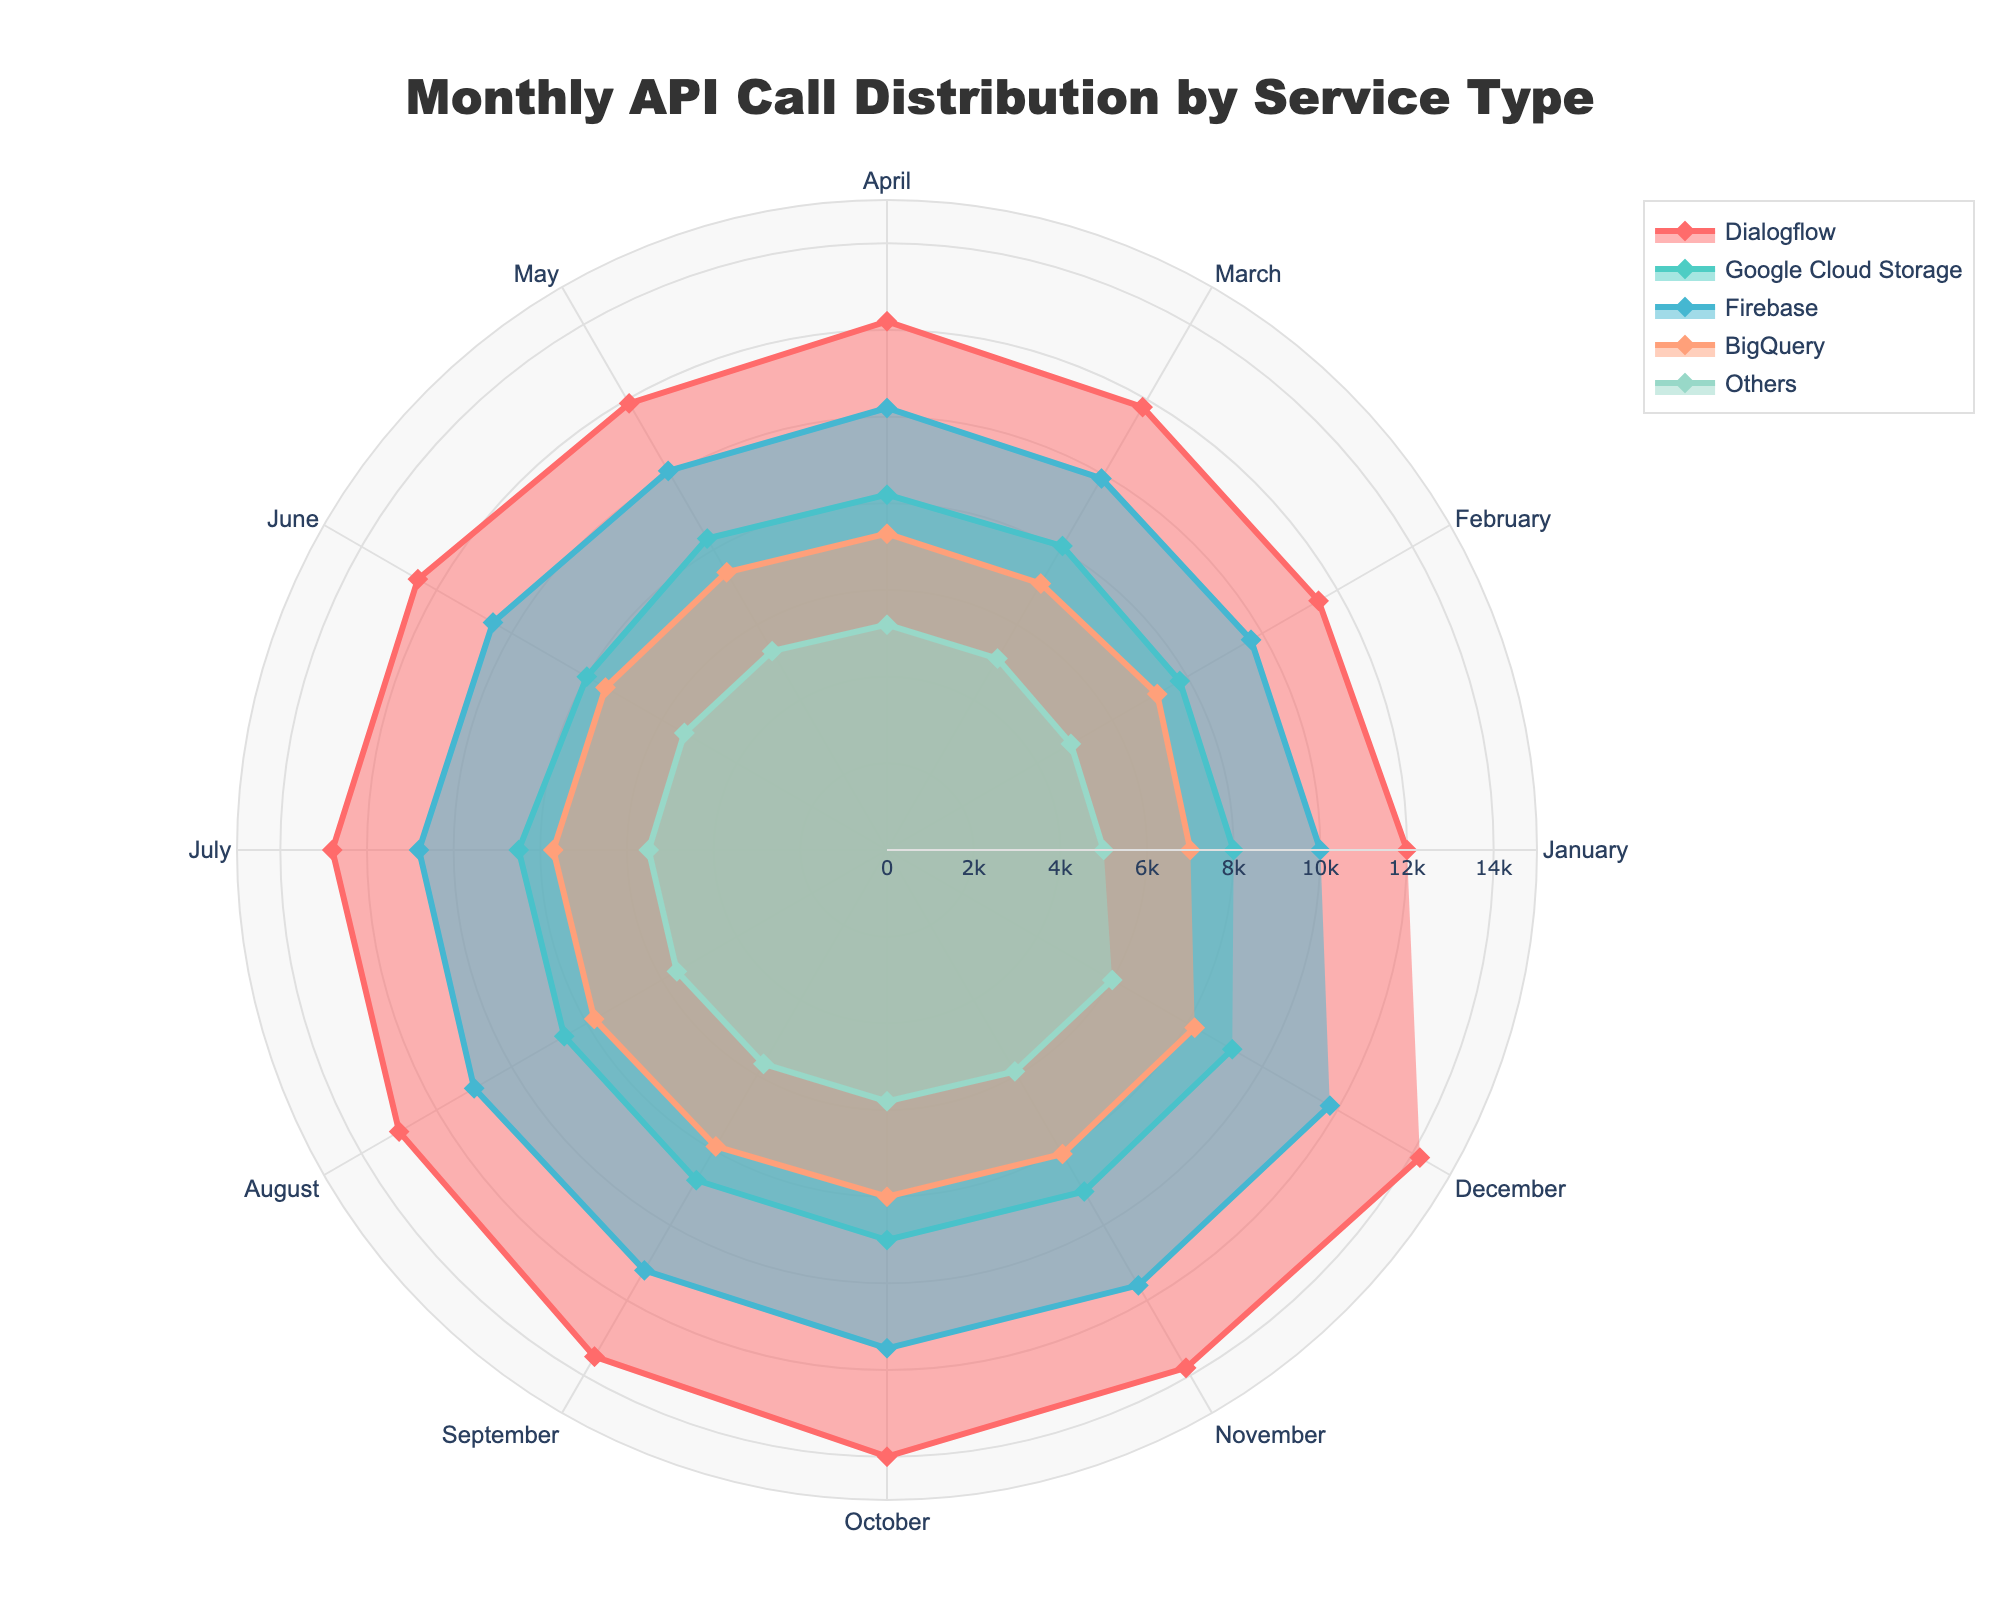What is the highest API call count for Dialogflow? From the Polar Chart, locate the trace called 'Dialogflow'. Find the maximum value along the radial axis for 'Dialogflow', which appears in December.
Answer: 14200 Which month has the lowest API call count for Google Cloud Storage? Look at the trace labeled 'Google Cloud Storage' and identify the lowest point on the radial axis, which occurs in February.
Answer: February For which months does Firebase have API call counts exceeding 11000? Check the trace for 'Firebase' and note the months where the radial value surpasses 11000. These months are August to December.
Answer: August, September, October, November, December What is the average API call count for BigQuery across all months? Sum all BigQuery values from January to December to get 92200. Then, divide by the number of months (12) to get the average.
Answer: 7683.33 Compare the API call trends of Dialogflow and Firebase. Which one shows a steeper increase in the last six months? For Dialogflow, values increase from 12500 (June) to 14200 (December). For Firebase, values increase from 10500 (June) to 11800 (December). The increase for Dialogflow is 1700 vs. Firebase's increase of 1300, indicating that Dialogflow has a steeper increase.
Answer: Dialogflow What is the total count of API calls made by the “Others” service type over the year? Sum the values for 'Others' from January to December (5000 + 4900 + 5100 + 5200 + 5300 + 5400 + 5500 + 5600 + 5700 + 5800 + 5900 + 6000) to get the total.
Answer: 66400 How does the API call count for Google Cloud Storage in October compare to that of Dialogflow in the same month? Look at the radial values for October in both the Google Cloud Storage and Dialogflow traces: Google Cloud Storage has 9000, and Dialogflow has 14000. Comparing these, Google Cloud Storage has fewer API calls in October.
Answer: Google Cloud Storage has fewer During which month does BigQuery surpass 8000 API calls only? Identify the point in the 'BigQuery' trace where the radial value first exceeds 8000. This first occurs in October.
Answer: October Which service type has the most consistent API call count throughout the year? Assess the stability of the radial values month to month for each service type. BigQuery’s values range from 7000 to 8200, showing the least variation.
Answer: BigQuery What is the difference between the highest and lowest API call counts for Dialogflow? Identify the highest value (14200 in December) and the lowest value (11500 in February) for Dialogflow. Subtract the lowest from the highest.
Answer: 2700 